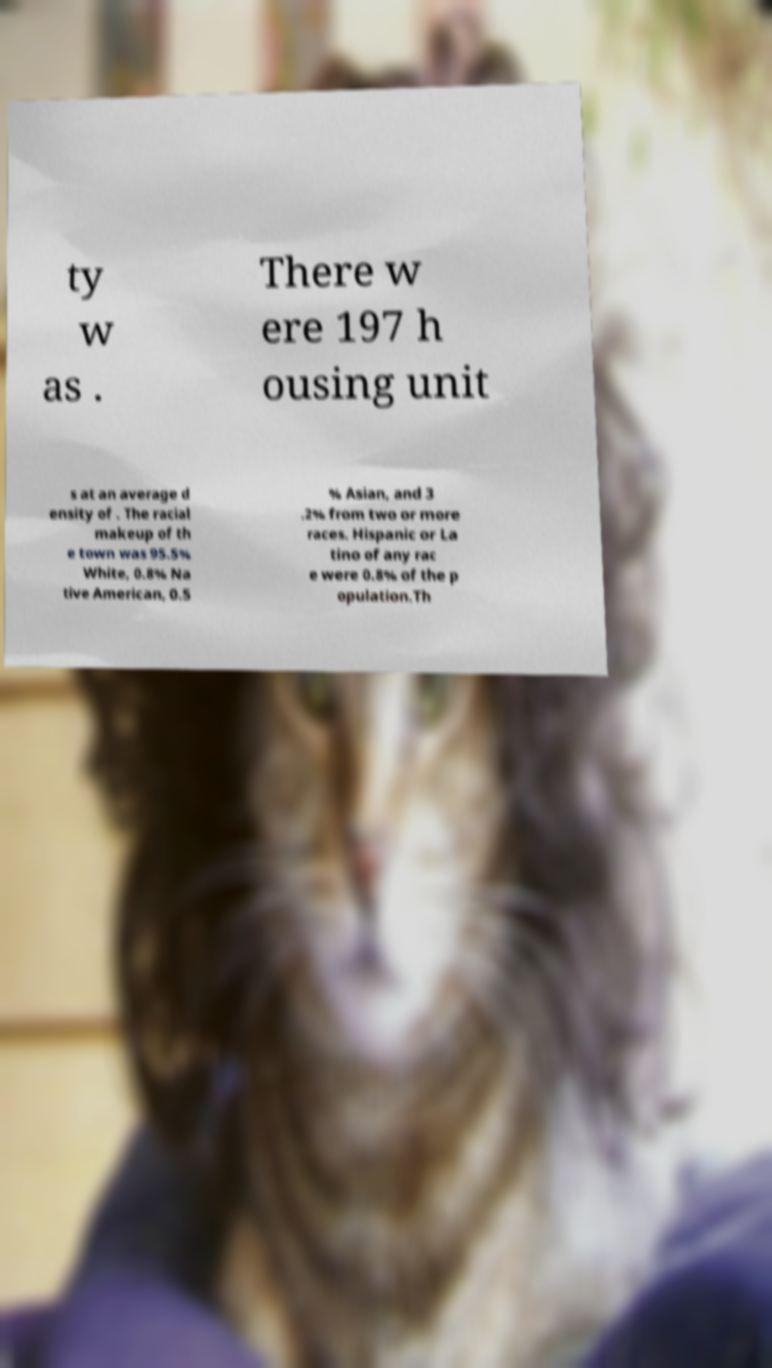Can you accurately transcribe the text from the provided image for me? ty w as . There w ere 197 h ousing unit s at an average d ensity of . The racial makeup of th e town was 95.5% White, 0.8% Na tive American, 0.5 % Asian, and 3 .2% from two or more races. Hispanic or La tino of any rac e were 0.8% of the p opulation.Th 